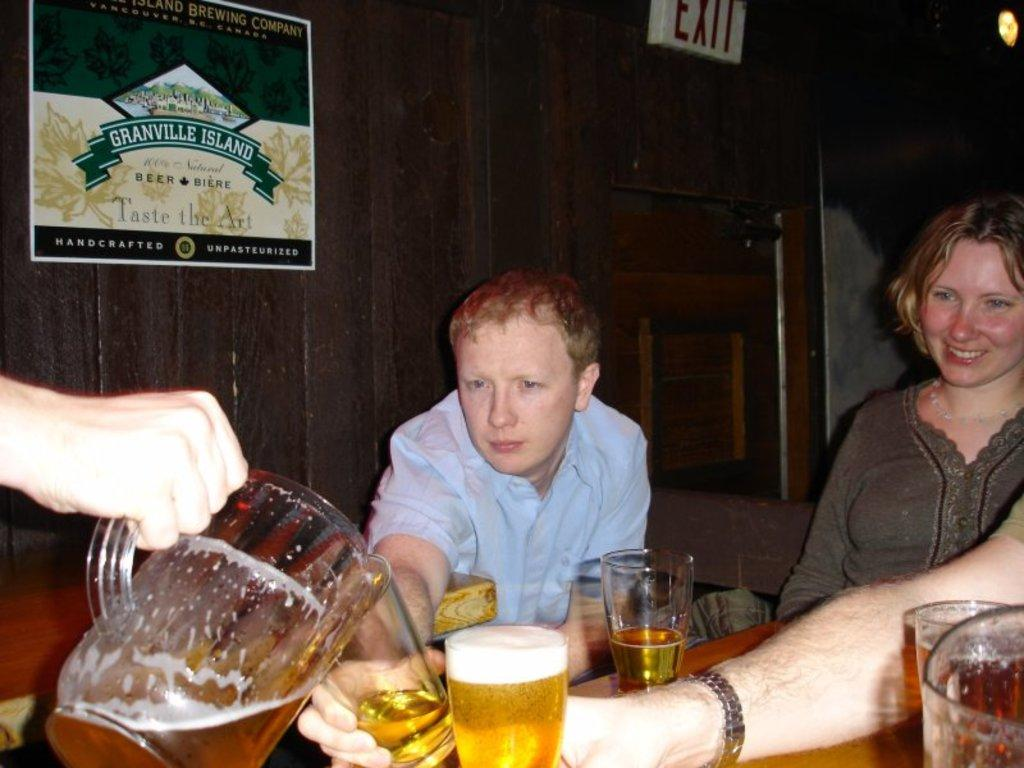How many people are in the image? There are two people in the image. What are the people doing in the image? The people are sitting on chairs. What is in front of the chairs? There is a table in front of the chairs. What can be seen on the table? There are glasses on the table. What is behind the people? There is a wall behind the people. What is on the wall? There is a poster on the wall. How many bikes are parked next to the stream in the image? There is no stream or bikes present in the image. 